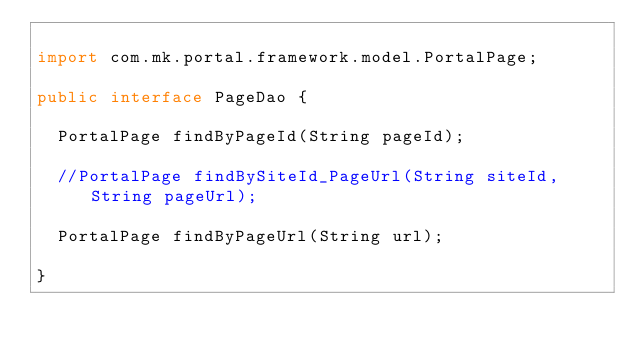<code> <loc_0><loc_0><loc_500><loc_500><_Java_>
import com.mk.portal.framework.model.PortalPage;

public interface PageDao {

	PortalPage findByPageId(String pageId);

	//PortalPage findBySiteId_PageUrl(String siteId, String pageUrl);

	PortalPage findByPageUrl(String url);

}
</code> 